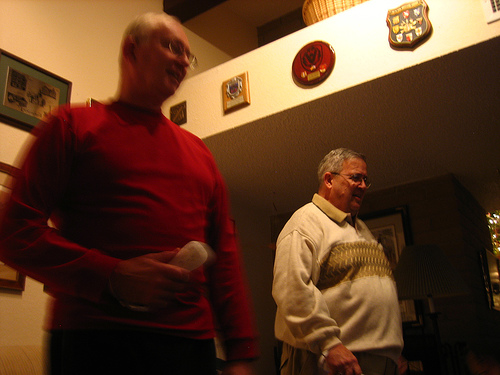What is the device to the left of the guy that is wearing a sweater? To the left of the gentleman wearing a cream-colored sweater, there appears to be a dark-colored remote control on the table. 